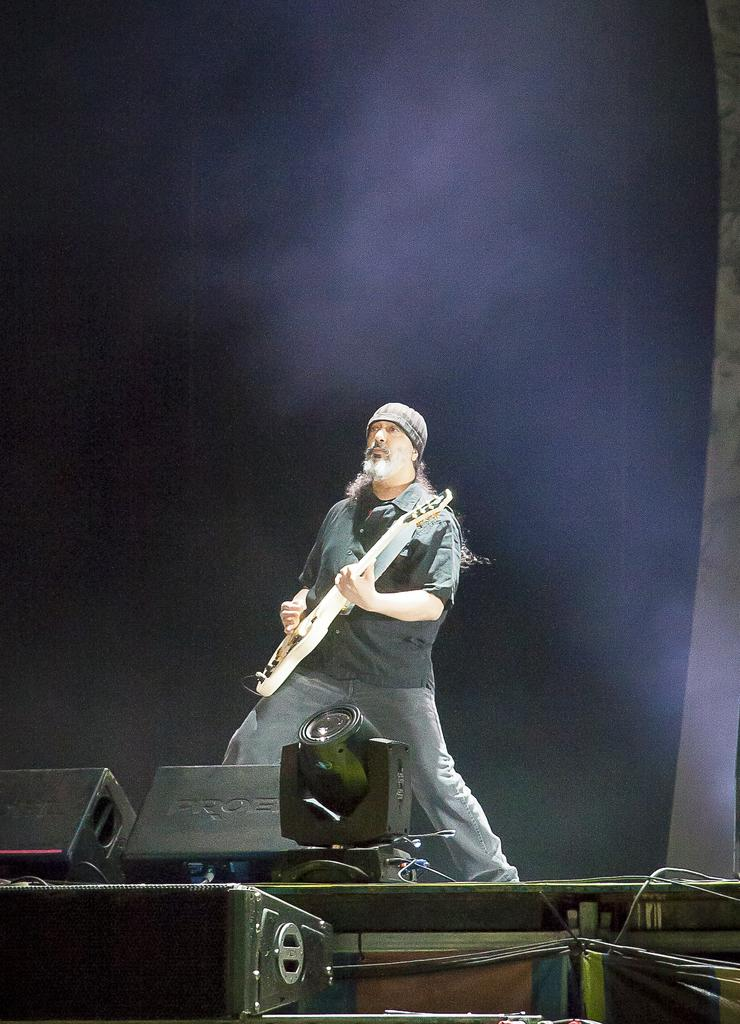What is the main subject of the image? There is a person in the image. What is the person doing in the image? The person is standing and holding a guitar. Can you describe any other elements in the image? There is a light visible in the image. What type of trail can be seen behind the person in the image? There is no trail visible in the image; it only features a person standing and holding a guitar, along with a light. How many bites has the person taken out of the guitar in the image? There are no bites taken out of the guitar in the image; the person is simply holding it. 